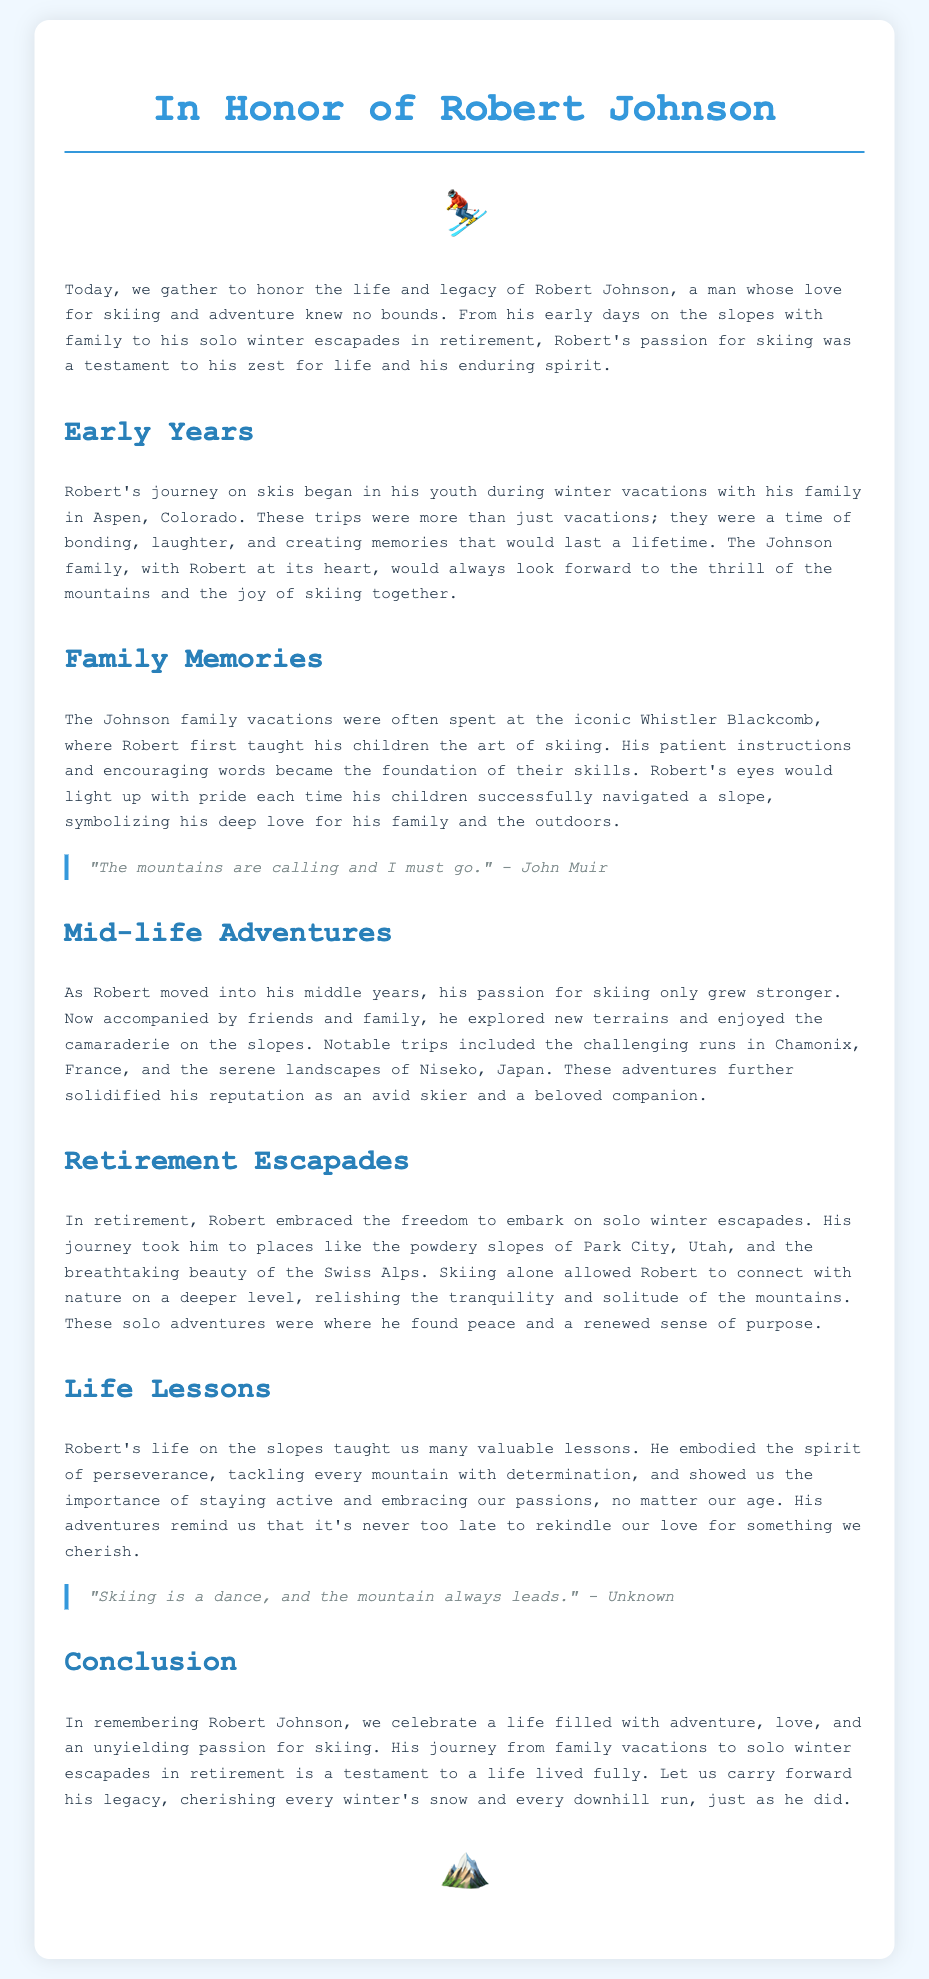what was Robert Johnson's favorite winter destination with family? The document states that the preferred vacation spot for the Johnson family was Aspen, Colorado, where Robert began skiing.
Answer: Aspen, Colorado which family ski resort was mentioned in relation to Robert's children? The eulogy mentions that Robert taught his children to ski at the iconic Whistler Blackcomb.
Answer: Whistler Blackcomb name one location Robert visited during his solo skiing adventures. The document lists several locations, including the Swiss Alps, which Robert enjoyed during his retirement escapades.
Answer: Swiss Alps what lesson about life did Robert's skiing adventures emphasize? The text highlights the importance of perseverance and embracing our passions regardless of age as a key life lesson learned from Robert's skiing experiences.
Answer: perseverance who is quoted saying, "The mountains are calling and I must go"? The quote in the document is attributed to John Muir, indicating a connection between skiing and nature.
Answer: John Muir how did skiing affect Robert's sense of purpose in retirement? The eulogy explains that skiing alone allowed Robert to connect with nature deeply, providing him with tranquility and a renewed sense of purpose.
Answer: tranquility and purpose what was Robert's skiing attitude during mid-life adventures? The document describes Robert's skiing as enhanced by the enjoyment of camaraderie when skiing with friends and family during his mid-life adventures.
Answer: camaraderie what does the eulogy conclude about Robert Johnson's legacy? The conclusion emphasizes celebrating Robert’s adventurous life and encourages others to cherish winter sports just like he did.
Answer: cherish winter sports 